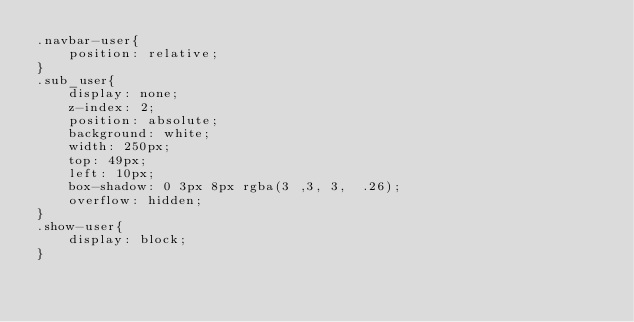Convert code to text. <code><loc_0><loc_0><loc_500><loc_500><_CSS_>.navbar-user{
    position: relative;
}
.sub_user{
    display: none;
    z-index: 2;
    position: absolute;
    background: white;
    width: 250px;
    top: 49px;
    left: 10px;
    box-shadow: 0 3px 8px rgba(3 ,3, 3,  .26);
    overflow: hidden;
}
.show-user{
    display: block;
}
</code> 